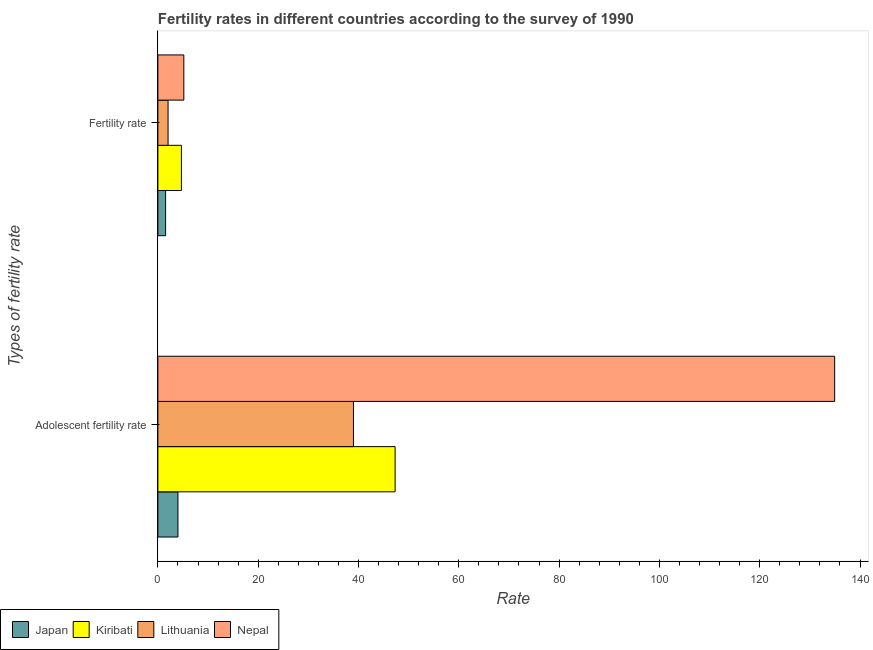How many different coloured bars are there?
Offer a terse response. 4. How many groups of bars are there?
Ensure brevity in your answer.  2. How many bars are there on the 1st tick from the top?
Provide a succinct answer. 4. How many bars are there on the 2nd tick from the bottom?
Provide a short and direct response. 4. What is the label of the 1st group of bars from the top?
Your response must be concise. Fertility rate. What is the adolescent fertility rate in Japan?
Make the answer very short. 4. Across all countries, what is the maximum fertility rate?
Give a very brief answer. 5.17. In which country was the adolescent fertility rate maximum?
Your response must be concise. Nepal. In which country was the adolescent fertility rate minimum?
Keep it short and to the point. Japan. What is the total adolescent fertility rate in the graph?
Offer a terse response. 225.24. What is the difference between the fertility rate in Nepal and that in Lithuania?
Provide a short and direct response. 3.14. What is the difference between the adolescent fertility rate in Lithuania and the fertility rate in Nepal?
Offer a terse response. 33.83. What is the average fertility rate per country?
Make the answer very short. 3.36. What is the difference between the fertility rate and adolescent fertility rate in Lithuania?
Offer a very short reply. -36.97. What is the ratio of the fertility rate in Lithuania to that in Japan?
Keep it short and to the point. 1.32. Is the fertility rate in Japan less than that in Lithuania?
Your answer should be very brief. Yes. What does the 2nd bar from the top in Fertility rate represents?
Provide a short and direct response. Lithuania. What does the 3rd bar from the bottom in Adolescent fertility rate represents?
Provide a succinct answer. Lithuania. How many bars are there?
Ensure brevity in your answer.  8. Are all the bars in the graph horizontal?
Keep it short and to the point. Yes. How many countries are there in the graph?
Ensure brevity in your answer.  4. Does the graph contain grids?
Provide a short and direct response. No. Where does the legend appear in the graph?
Provide a short and direct response. Bottom left. How are the legend labels stacked?
Your response must be concise. Horizontal. What is the title of the graph?
Provide a succinct answer. Fertility rates in different countries according to the survey of 1990. Does "Congo (Republic)" appear as one of the legend labels in the graph?
Your answer should be very brief. No. What is the label or title of the X-axis?
Keep it short and to the point. Rate. What is the label or title of the Y-axis?
Your answer should be very brief. Types of fertility rate. What is the Rate in Japan in Adolescent fertility rate?
Your answer should be compact. 4. What is the Rate of Kiribati in Adolescent fertility rate?
Offer a very short reply. 47.3. What is the Rate of Lithuania in Adolescent fertility rate?
Make the answer very short. 39. What is the Rate of Nepal in Adolescent fertility rate?
Keep it short and to the point. 134.94. What is the Rate in Japan in Fertility rate?
Your response must be concise. 1.54. What is the Rate of Kiribati in Fertility rate?
Provide a short and direct response. 4.69. What is the Rate in Lithuania in Fertility rate?
Keep it short and to the point. 2.03. What is the Rate in Nepal in Fertility rate?
Provide a succinct answer. 5.17. Across all Types of fertility rate, what is the maximum Rate of Japan?
Make the answer very short. 4. Across all Types of fertility rate, what is the maximum Rate in Kiribati?
Your answer should be compact. 47.3. Across all Types of fertility rate, what is the maximum Rate of Lithuania?
Your response must be concise. 39. Across all Types of fertility rate, what is the maximum Rate in Nepal?
Keep it short and to the point. 134.94. Across all Types of fertility rate, what is the minimum Rate of Japan?
Your response must be concise. 1.54. Across all Types of fertility rate, what is the minimum Rate of Kiribati?
Provide a succinct answer. 4.69. Across all Types of fertility rate, what is the minimum Rate in Lithuania?
Give a very brief answer. 2.03. Across all Types of fertility rate, what is the minimum Rate of Nepal?
Give a very brief answer. 5.17. What is the total Rate in Japan in the graph?
Keep it short and to the point. 5.54. What is the total Rate in Kiribati in the graph?
Make the answer very short. 51.99. What is the total Rate of Lithuania in the graph?
Provide a succinct answer. 41.03. What is the total Rate in Nepal in the graph?
Your answer should be compact. 140.12. What is the difference between the Rate of Japan in Adolescent fertility rate and that in Fertility rate?
Provide a succinct answer. 2.46. What is the difference between the Rate in Kiribati in Adolescent fertility rate and that in Fertility rate?
Make the answer very short. 42.61. What is the difference between the Rate in Lithuania in Adolescent fertility rate and that in Fertility rate?
Make the answer very short. 36.97. What is the difference between the Rate in Nepal in Adolescent fertility rate and that in Fertility rate?
Your answer should be compact. 129.77. What is the difference between the Rate in Japan in Adolescent fertility rate and the Rate in Kiribati in Fertility rate?
Provide a short and direct response. -0.69. What is the difference between the Rate of Japan in Adolescent fertility rate and the Rate of Lithuania in Fertility rate?
Give a very brief answer. 1.97. What is the difference between the Rate of Japan in Adolescent fertility rate and the Rate of Nepal in Fertility rate?
Keep it short and to the point. -1.17. What is the difference between the Rate in Kiribati in Adolescent fertility rate and the Rate in Lithuania in Fertility rate?
Give a very brief answer. 45.27. What is the difference between the Rate of Kiribati in Adolescent fertility rate and the Rate of Nepal in Fertility rate?
Offer a terse response. 42.13. What is the difference between the Rate in Lithuania in Adolescent fertility rate and the Rate in Nepal in Fertility rate?
Your answer should be very brief. 33.83. What is the average Rate in Japan per Types of fertility rate?
Provide a succinct answer. 2.77. What is the average Rate in Kiribati per Types of fertility rate?
Your response must be concise. 25.99. What is the average Rate in Lithuania per Types of fertility rate?
Provide a succinct answer. 20.51. What is the average Rate of Nepal per Types of fertility rate?
Keep it short and to the point. 70.06. What is the difference between the Rate in Japan and Rate in Kiribati in Adolescent fertility rate?
Provide a short and direct response. -43.3. What is the difference between the Rate in Japan and Rate in Lithuania in Adolescent fertility rate?
Offer a very short reply. -35. What is the difference between the Rate in Japan and Rate in Nepal in Adolescent fertility rate?
Your response must be concise. -130.94. What is the difference between the Rate of Kiribati and Rate of Lithuania in Adolescent fertility rate?
Your answer should be compact. 8.3. What is the difference between the Rate of Kiribati and Rate of Nepal in Adolescent fertility rate?
Your answer should be compact. -87.64. What is the difference between the Rate of Lithuania and Rate of Nepal in Adolescent fertility rate?
Your response must be concise. -95.95. What is the difference between the Rate of Japan and Rate of Kiribati in Fertility rate?
Provide a succinct answer. -3.15. What is the difference between the Rate of Japan and Rate of Lithuania in Fertility rate?
Your response must be concise. -0.49. What is the difference between the Rate in Japan and Rate in Nepal in Fertility rate?
Offer a terse response. -3.63. What is the difference between the Rate of Kiribati and Rate of Lithuania in Fertility rate?
Give a very brief answer. 2.66. What is the difference between the Rate in Kiribati and Rate in Nepal in Fertility rate?
Provide a succinct answer. -0.48. What is the difference between the Rate in Lithuania and Rate in Nepal in Fertility rate?
Ensure brevity in your answer.  -3.14. What is the ratio of the Rate of Japan in Adolescent fertility rate to that in Fertility rate?
Provide a succinct answer. 2.6. What is the ratio of the Rate of Kiribati in Adolescent fertility rate to that in Fertility rate?
Your answer should be compact. 10.09. What is the ratio of the Rate in Lithuania in Adolescent fertility rate to that in Fertility rate?
Provide a short and direct response. 19.21. What is the ratio of the Rate in Nepal in Adolescent fertility rate to that in Fertility rate?
Ensure brevity in your answer.  26.09. What is the difference between the highest and the second highest Rate in Japan?
Your answer should be compact. 2.46. What is the difference between the highest and the second highest Rate of Kiribati?
Offer a terse response. 42.61. What is the difference between the highest and the second highest Rate of Lithuania?
Your response must be concise. 36.97. What is the difference between the highest and the second highest Rate in Nepal?
Make the answer very short. 129.77. What is the difference between the highest and the lowest Rate in Japan?
Provide a succinct answer. 2.46. What is the difference between the highest and the lowest Rate of Kiribati?
Provide a short and direct response. 42.61. What is the difference between the highest and the lowest Rate of Lithuania?
Your answer should be very brief. 36.97. What is the difference between the highest and the lowest Rate of Nepal?
Your answer should be very brief. 129.77. 